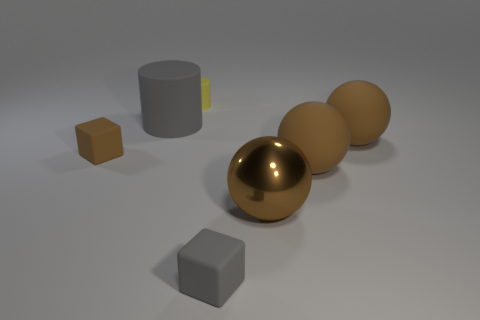Could you describe the lighting and shadows in the image? The lighting in the image seems to be coming from the upper left, as indicated by the shadows cast towards the lower right of the objects. The diffused lighting suggests an indoor setting with a soft, perhaps overcast light source. 